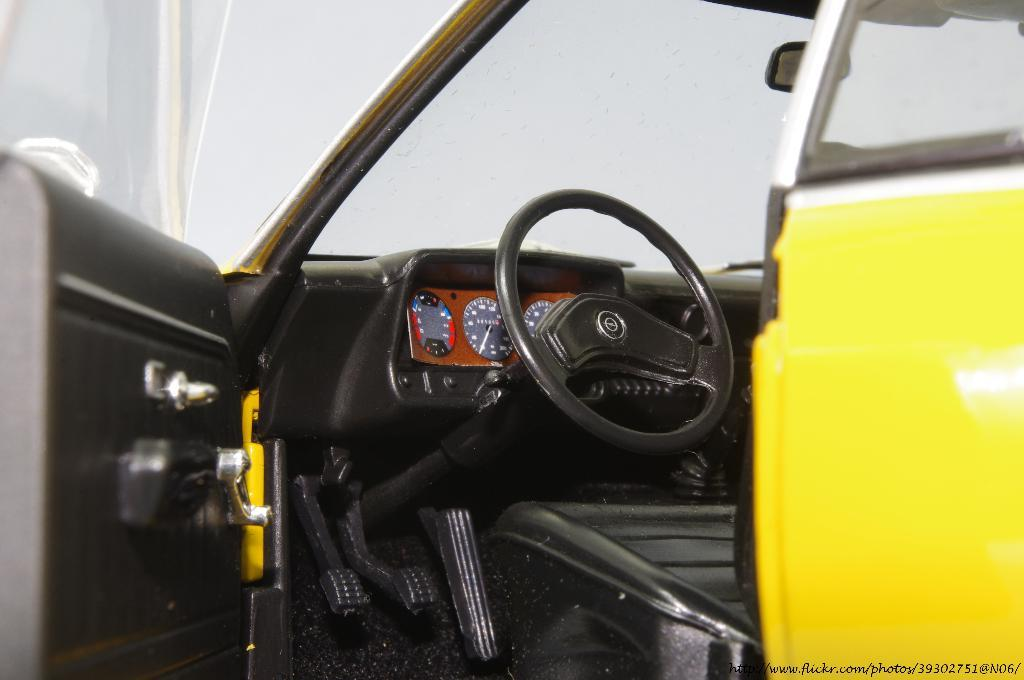What is the main object in the image? There is a steering wheel in the image. What other features can be seen related to the main object? There are gauges, a clutch, and a brake in the image. What type of structure is present in the image? There is a door and a seat in the image. What is the purpose of the windshield in the image? The windshield is present to provide a clear view of the road and protect the driver from wind and debris. What can be seen in the background of the image? The sky is visible in the background of the image. Can you see any pets in the image? There are no pets visible in the image. What type of cactus can be seen growing near the windshield in the image? There is no cactus present in the image; it is an interior scene with no plants visible. 